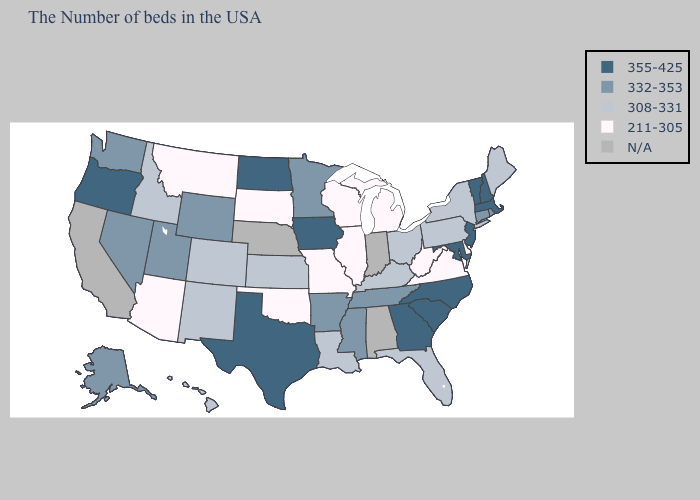What is the value of Arkansas?
Be succinct. 332-353. Among the states that border Massachusetts , does New Hampshire have the highest value?
Concise answer only. Yes. Does Oregon have the highest value in the USA?
Write a very short answer. Yes. What is the highest value in the USA?
Keep it brief. 355-425. Name the states that have a value in the range N/A?
Give a very brief answer. Indiana, Alabama, Nebraska, California. Is the legend a continuous bar?
Short answer required. No. Name the states that have a value in the range 211-305?
Write a very short answer. Delaware, Virginia, West Virginia, Michigan, Wisconsin, Illinois, Missouri, Oklahoma, South Dakota, Montana, Arizona. What is the highest value in the USA?
Quick response, please. 355-425. Does Louisiana have the lowest value in the USA?
Write a very short answer. No. Name the states that have a value in the range 308-331?
Quick response, please. Maine, New York, Pennsylvania, Ohio, Florida, Kentucky, Louisiana, Kansas, Colorado, New Mexico, Idaho, Hawaii. Among the states that border Nevada , which have the highest value?
Give a very brief answer. Oregon. What is the highest value in the USA?
Quick response, please. 355-425. What is the value of Alabama?
Give a very brief answer. N/A. Does the map have missing data?
Short answer required. Yes. 